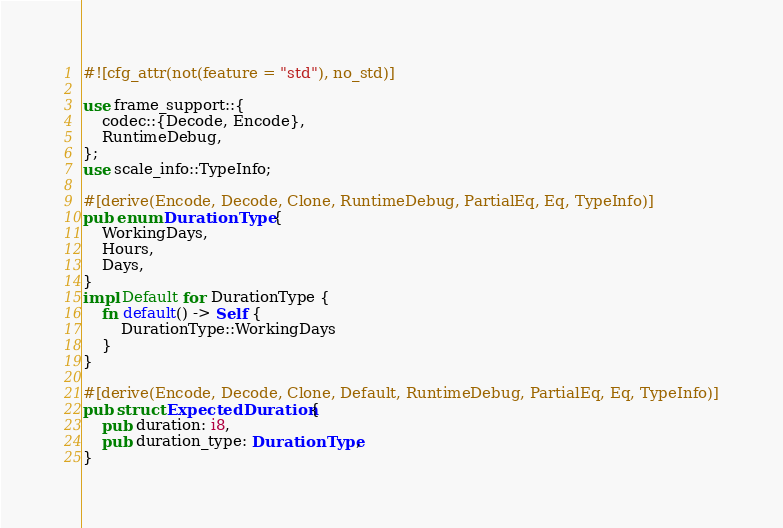<code> <loc_0><loc_0><loc_500><loc_500><_Rust_>#![cfg_attr(not(feature = "std"), no_std)]

use frame_support::{
	codec::{Decode, Encode},
	RuntimeDebug,
};
use scale_info::TypeInfo;

#[derive(Encode, Decode, Clone, RuntimeDebug, PartialEq, Eq, TypeInfo)]
pub enum DurationType {
	WorkingDays,
	Hours,
	Days,
}
impl Default for DurationType {
	fn default() -> Self {
		DurationType::WorkingDays
	}
}

#[derive(Encode, Decode, Clone, Default, RuntimeDebug, PartialEq, Eq, TypeInfo)]
pub struct ExpectedDuration {
	pub duration: i8,
	pub duration_type: DurationType,
}
</code> 